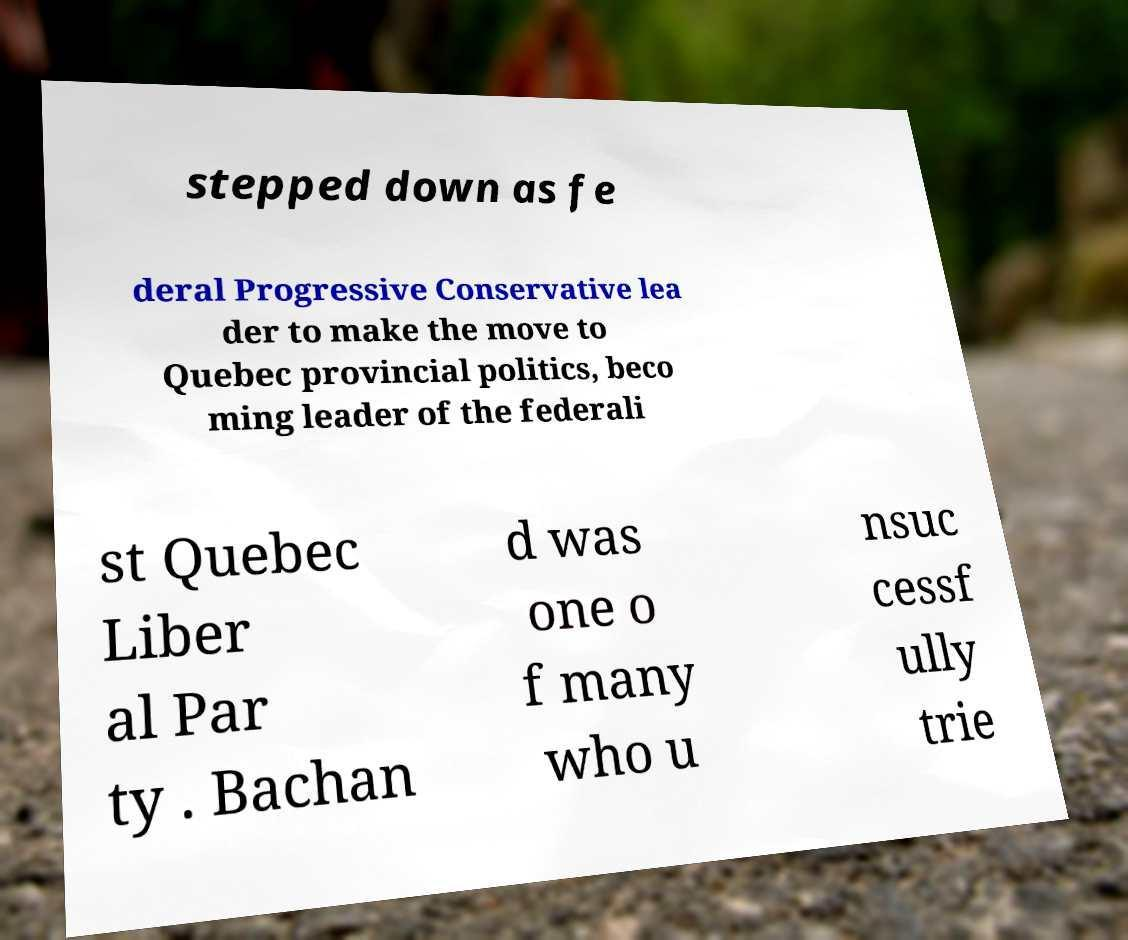What messages or text are displayed in this image? I need them in a readable, typed format. stepped down as fe deral Progressive Conservative lea der to make the move to Quebec provincial politics, beco ming leader of the federali st Quebec Liber al Par ty . Bachan d was one o f many who u nsuc cessf ully trie 